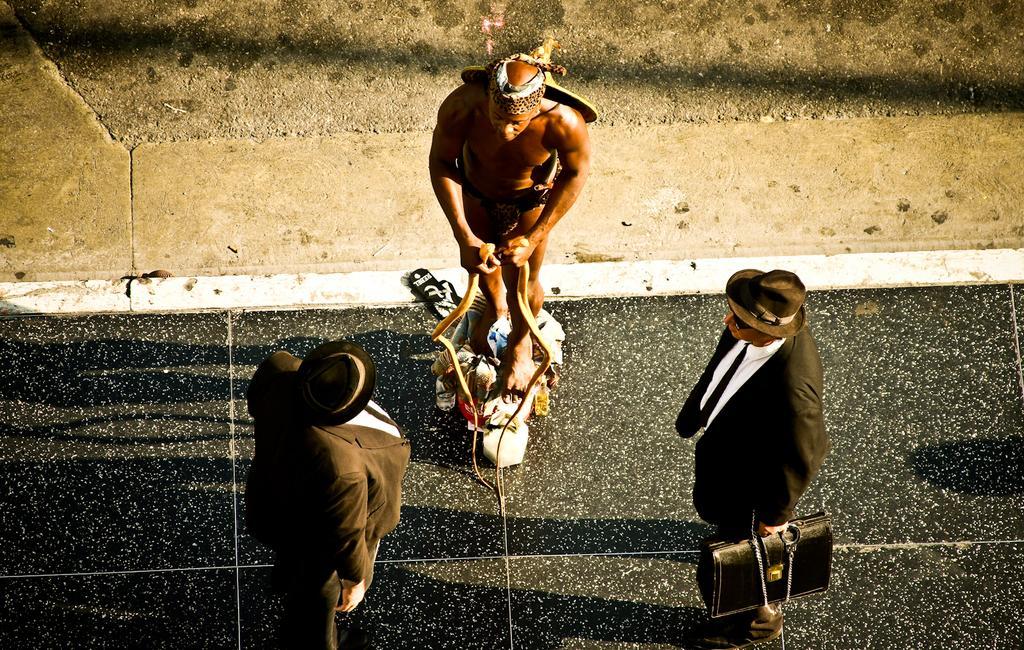Could you give a brief overview of what you see in this image? This image consists of three men. On the left and right, the to men wearing black suits and hats. In the middle, the man is standing on some objects. At the bottom, there is a floor. 